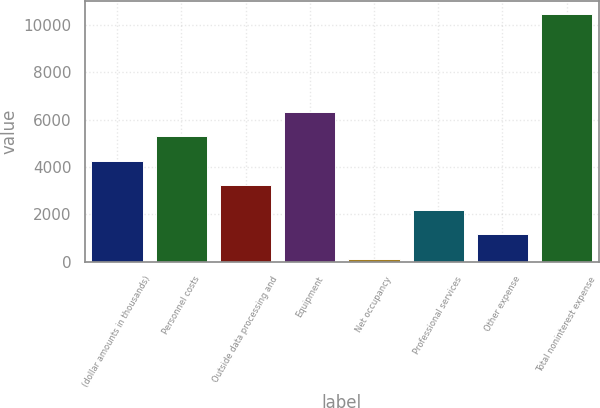Convert chart to OTSL. <chart><loc_0><loc_0><loc_500><loc_500><bar_chart><fcel>(dollar amounts in thousands)<fcel>Personnel costs<fcel>Outside data processing and<fcel>Equipment<fcel>Net occupancy<fcel>Professional services<fcel>Other expense<fcel>Total noninterest expense<nl><fcel>4262<fcel>5300<fcel>3224<fcel>6338<fcel>110<fcel>2186<fcel>1148<fcel>10490<nl></chart> 